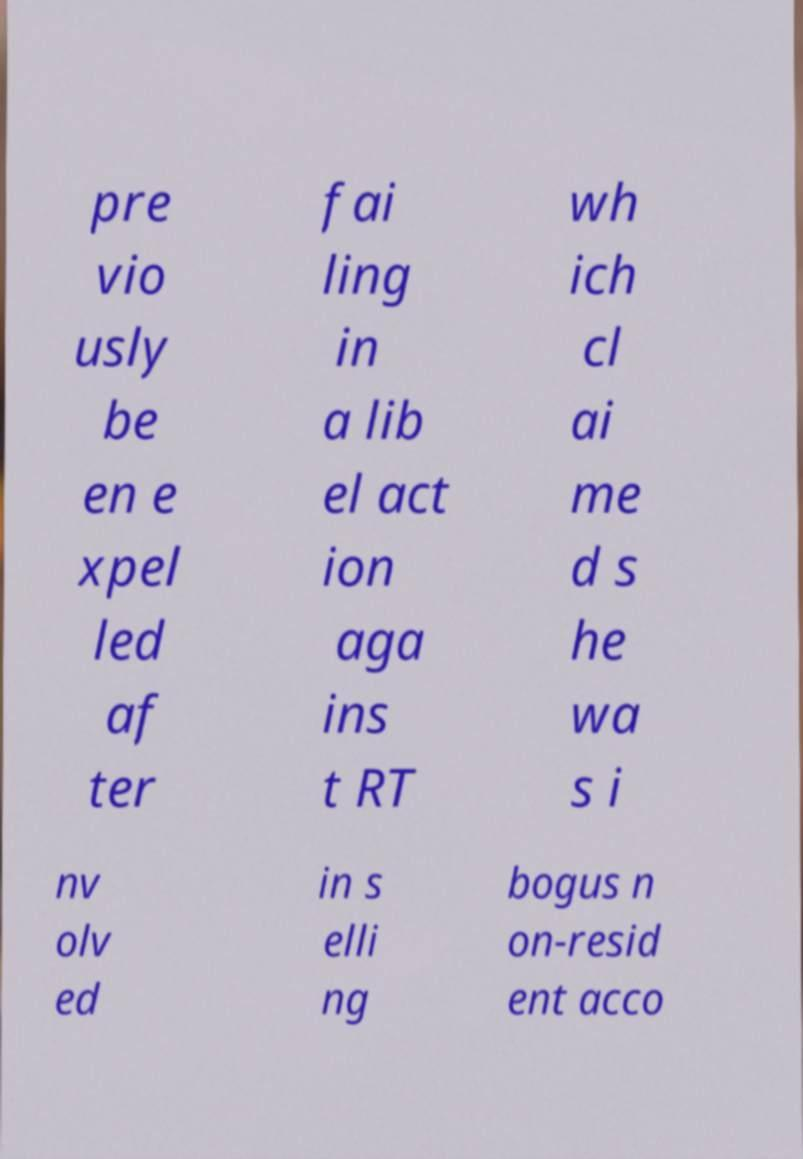Please identify and transcribe the text found in this image. pre vio usly be en e xpel led af ter fai ling in a lib el act ion aga ins t RT wh ich cl ai me d s he wa s i nv olv ed in s elli ng bogus n on-resid ent acco 